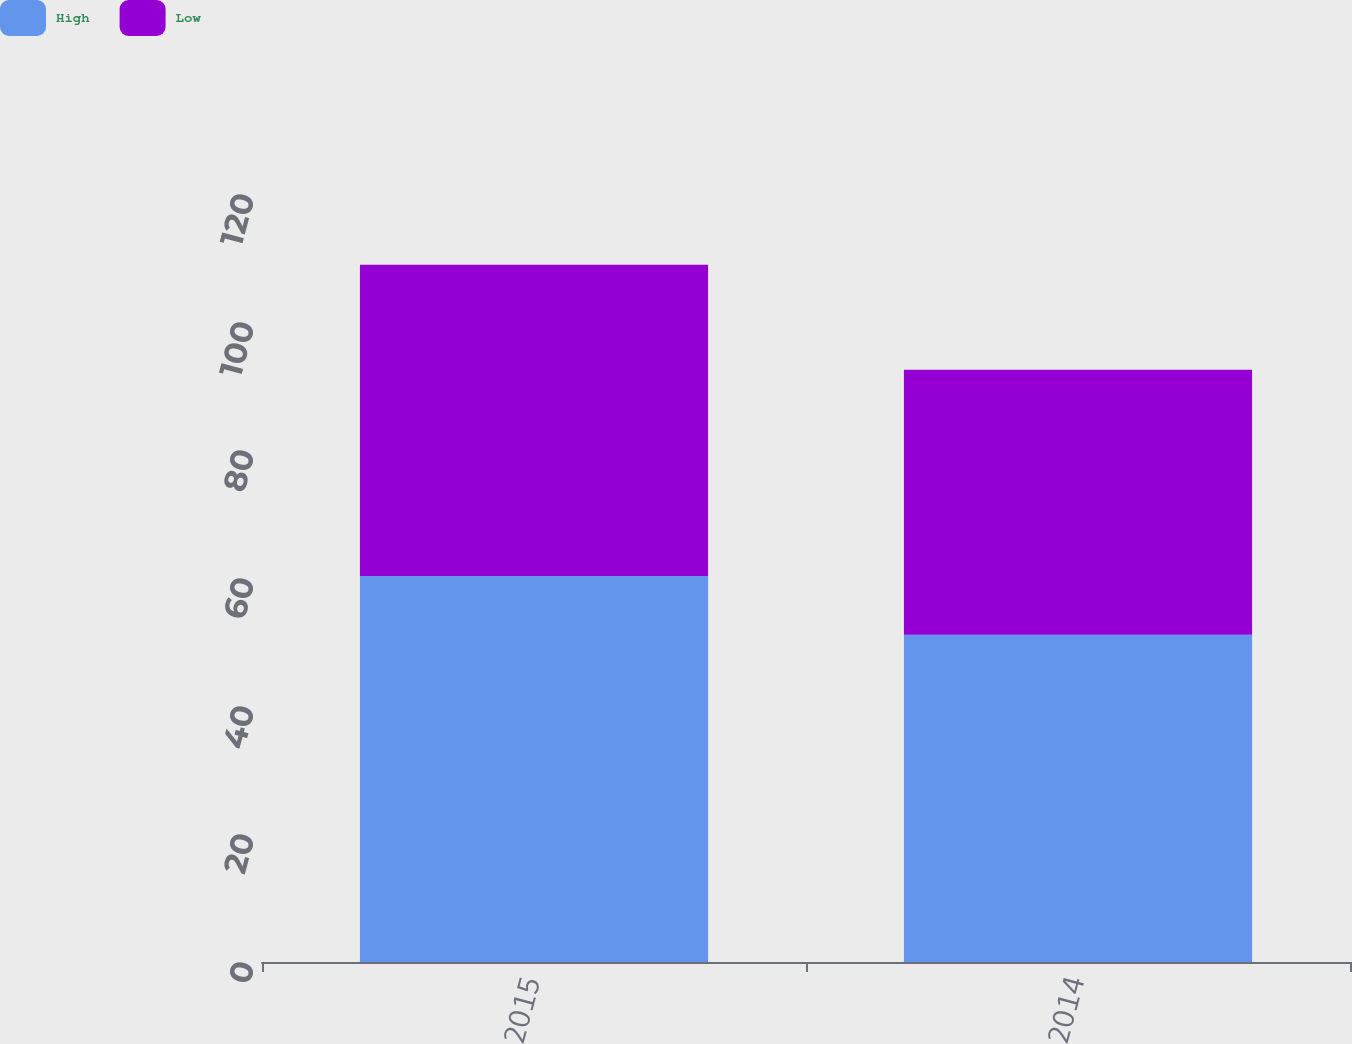<chart> <loc_0><loc_0><loc_500><loc_500><stacked_bar_chart><ecel><fcel>2015<fcel>2014<nl><fcel>High<fcel>60.3<fcel>51.12<nl><fcel>Low<fcel>48.66<fcel>41.41<nl></chart> 